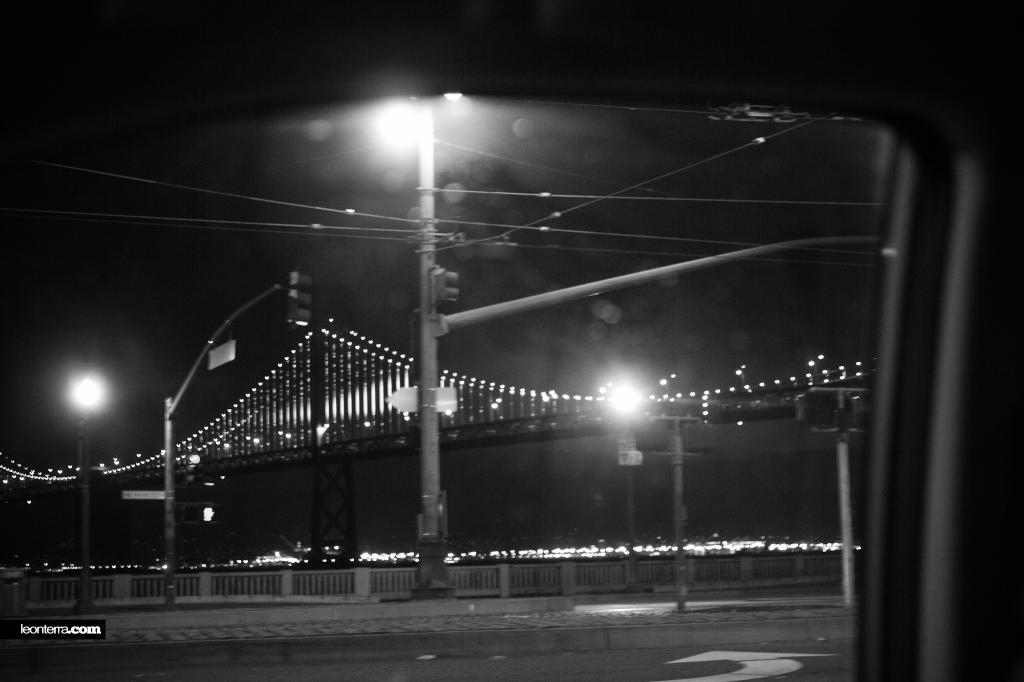What is the perspective of the image? The image was taken from inside a car. What can be seen on the ground in the image? There is a road visible in the image. What type of barrier is present in the image? There is a fence in the image. What type of structure is present in the image that carries electrical wires? There is an electric pole with wires in the image. What type of infrastructure is present in the image that allows vehicles to cross over a body of water or obstacle? There is a bridge in the image. What type of respect can be seen on the bridge in the image? There is no indication of respect in the image, as it is a photograph of a bridge and does not depict any human interactions or emotions. 